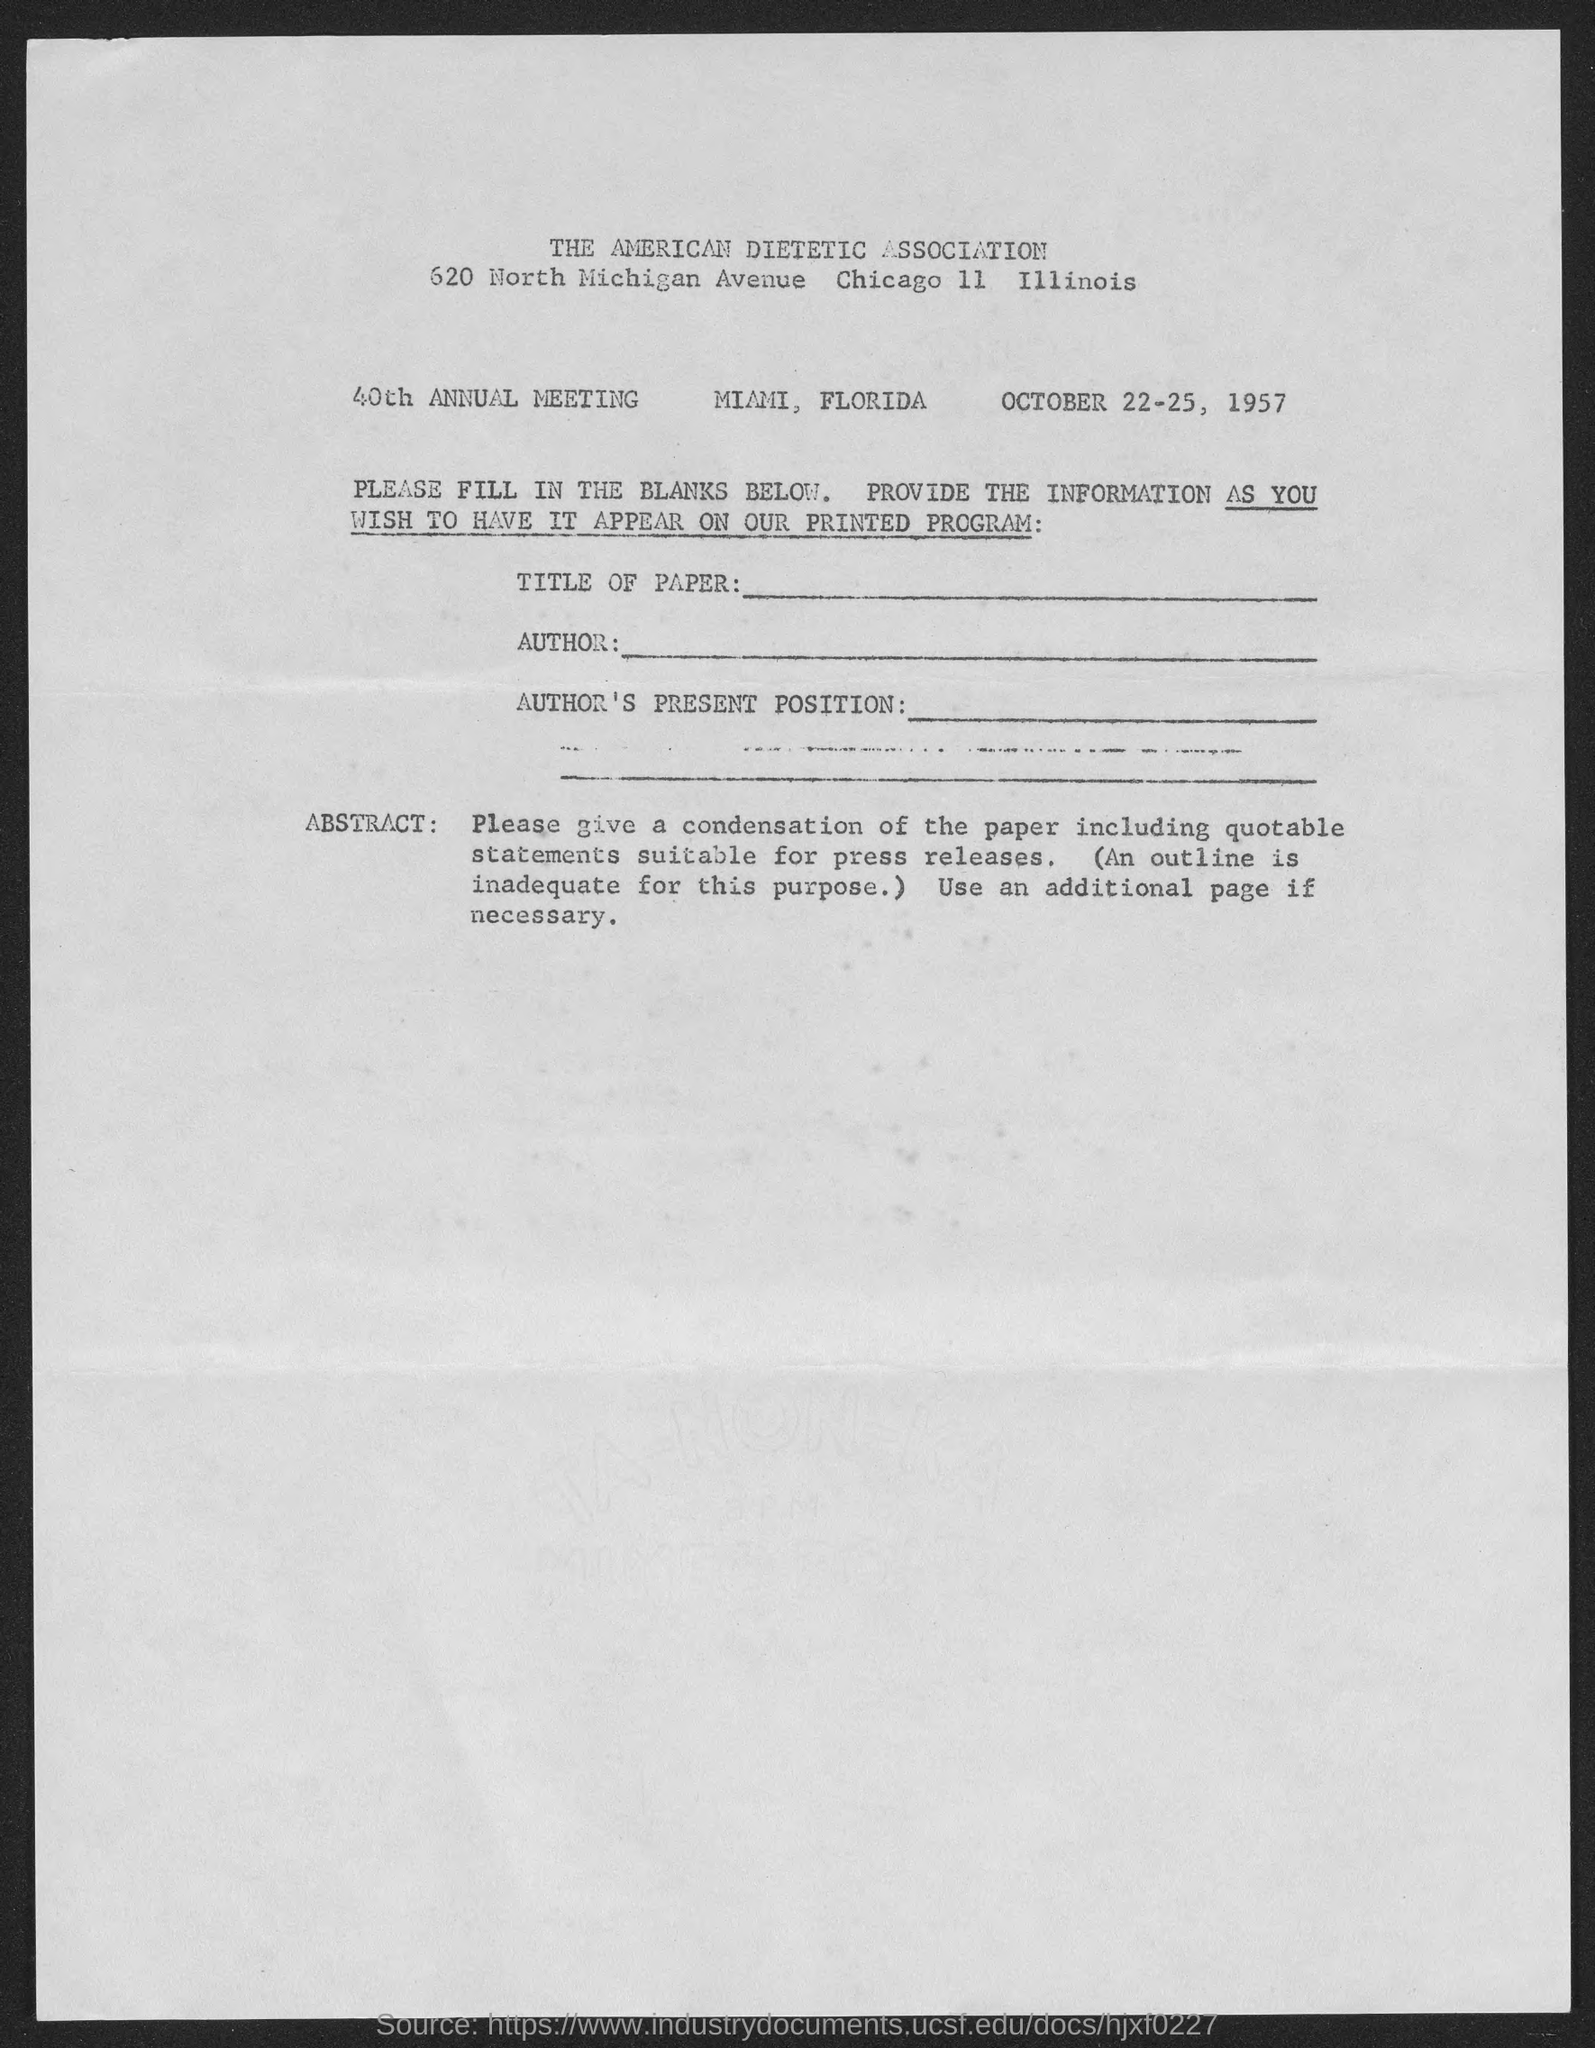What is the name of the association conducting the meeting?
Give a very brief answer. The American dietetic association. What is the date given in the form?
Offer a terse response. October 22-25, 1957. What is the address of american dietetic association given in the form?
Keep it short and to the point. 620 north michigan avenue chicago 11 illinois. 